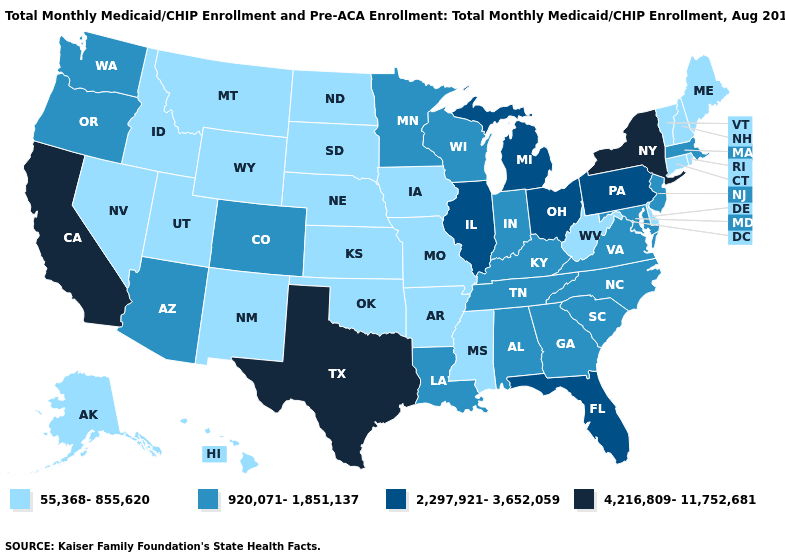What is the value of California?
Answer briefly. 4,216,809-11,752,681. What is the highest value in the USA?
Write a very short answer. 4,216,809-11,752,681. What is the value of Colorado?
Quick response, please. 920,071-1,851,137. What is the value of Washington?
Short answer required. 920,071-1,851,137. Does Rhode Island have the lowest value in the Northeast?
Answer briefly. Yes. Does Texas have the highest value in the South?
Answer briefly. Yes. Name the states that have a value in the range 55,368-855,620?
Concise answer only. Alaska, Arkansas, Connecticut, Delaware, Hawaii, Idaho, Iowa, Kansas, Maine, Mississippi, Missouri, Montana, Nebraska, Nevada, New Hampshire, New Mexico, North Dakota, Oklahoma, Rhode Island, South Dakota, Utah, Vermont, West Virginia, Wyoming. Does New Jersey have the lowest value in the Northeast?
Give a very brief answer. No. Does Hawaii have a lower value than Texas?
Answer briefly. Yes. Among the states that border Oregon , which have the lowest value?
Give a very brief answer. Idaho, Nevada. Which states have the highest value in the USA?
Quick response, please. California, New York, Texas. Which states have the lowest value in the Northeast?
Keep it brief. Connecticut, Maine, New Hampshire, Rhode Island, Vermont. Name the states that have a value in the range 4,216,809-11,752,681?
Short answer required. California, New York, Texas. Name the states that have a value in the range 55,368-855,620?
Short answer required. Alaska, Arkansas, Connecticut, Delaware, Hawaii, Idaho, Iowa, Kansas, Maine, Mississippi, Missouri, Montana, Nebraska, Nevada, New Hampshire, New Mexico, North Dakota, Oklahoma, Rhode Island, South Dakota, Utah, Vermont, West Virginia, Wyoming. Name the states that have a value in the range 4,216,809-11,752,681?
Be succinct. California, New York, Texas. 